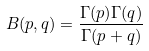Convert formula to latex. <formula><loc_0><loc_0><loc_500><loc_500>B ( p , q ) = \frac { \Gamma ( p ) \Gamma ( q ) } { \Gamma ( p + q ) }</formula> 